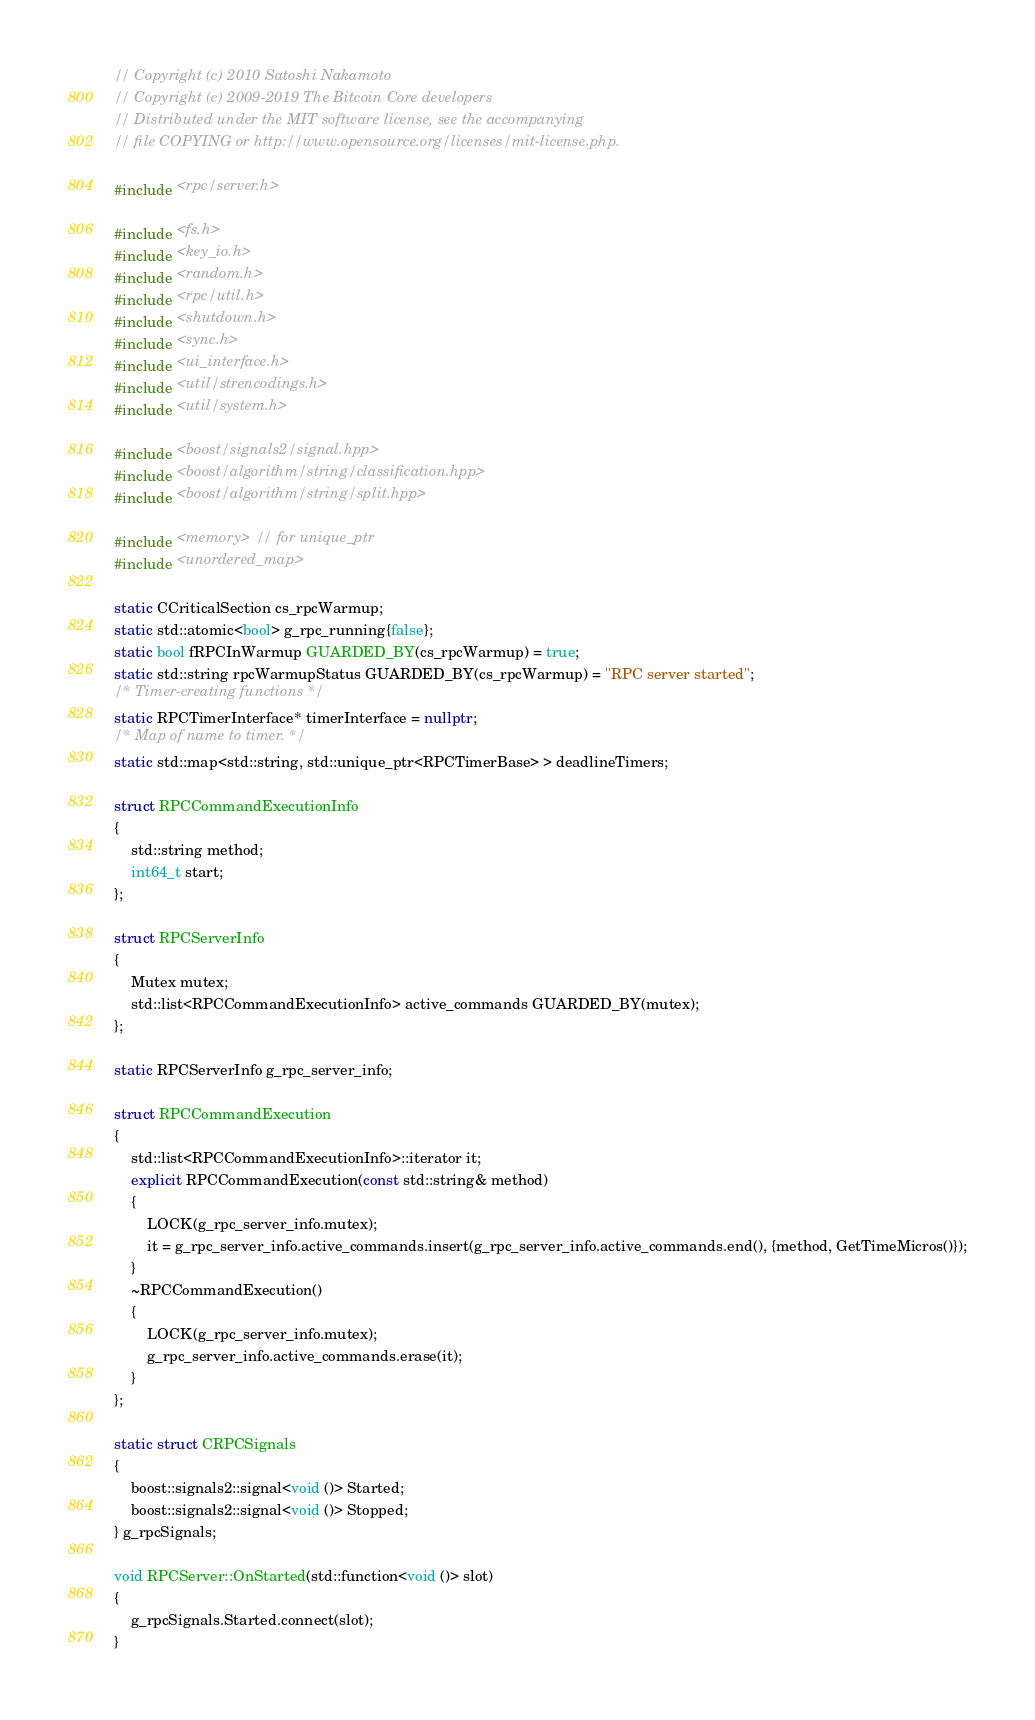Convert code to text. <code><loc_0><loc_0><loc_500><loc_500><_C++_>// Copyright (c) 2010 Satoshi Nakamoto
// Copyright (c) 2009-2019 The Bitcoin Core developers
// Distributed under the MIT software license, see the accompanying
// file COPYING or http://www.opensource.org/licenses/mit-license.php.

#include <rpc/server.h>

#include <fs.h>
#include <key_io.h>
#include <random.h>
#include <rpc/util.h>
#include <shutdown.h>
#include <sync.h>
#include <ui_interface.h>
#include <util/strencodings.h>
#include <util/system.h>

#include <boost/signals2/signal.hpp>
#include <boost/algorithm/string/classification.hpp>
#include <boost/algorithm/string/split.hpp>

#include <memory> // for unique_ptr
#include <unordered_map>

static CCriticalSection cs_rpcWarmup;
static std::atomic<bool> g_rpc_running{false};
static bool fRPCInWarmup GUARDED_BY(cs_rpcWarmup) = true;
static std::string rpcWarmupStatus GUARDED_BY(cs_rpcWarmup) = "RPC server started";
/* Timer-creating functions */
static RPCTimerInterface* timerInterface = nullptr;
/* Map of name to timer. */
static std::map<std::string, std::unique_ptr<RPCTimerBase> > deadlineTimers;

struct RPCCommandExecutionInfo
{
    std::string method;
    int64_t start;
};

struct RPCServerInfo
{
    Mutex mutex;
    std::list<RPCCommandExecutionInfo> active_commands GUARDED_BY(mutex);
};

static RPCServerInfo g_rpc_server_info;

struct RPCCommandExecution
{
    std::list<RPCCommandExecutionInfo>::iterator it;
    explicit RPCCommandExecution(const std::string& method)
    {
        LOCK(g_rpc_server_info.mutex);
        it = g_rpc_server_info.active_commands.insert(g_rpc_server_info.active_commands.end(), {method, GetTimeMicros()});
    }
    ~RPCCommandExecution()
    {
        LOCK(g_rpc_server_info.mutex);
        g_rpc_server_info.active_commands.erase(it);
    }
};

static struct CRPCSignals
{
    boost::signals2::signal<void ()> Started;
    boost::signals2::signal<void ()> Stopped;
} g_rpcSignals;

void RPCServer::OnStarted(std::function<void ()> slot)
{
    g_rpcSignals.Started.connect(slot);
}
</code> 